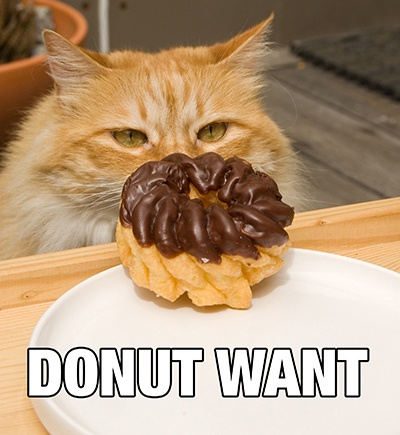Describe the objects in this image and their specific colors. I can see cat in maroon, tan, and olive tones, donut in maroon, orange, brown, and gray tones, and bowl in maroon, brown, and black tones in this image. 